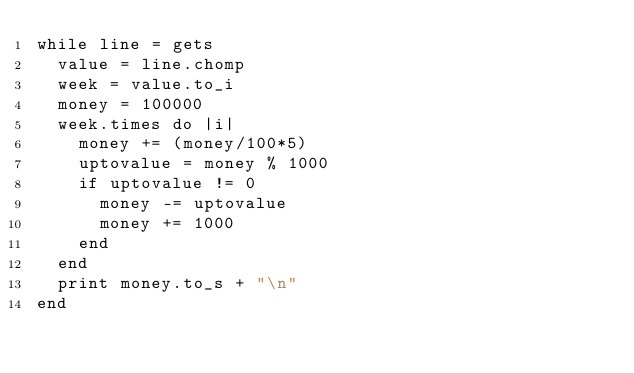Convert code to text. <code><loc_0><loc_0><loc_500><loc_500><_Ruby_>while line = gets
  value = line.chomp
  week = value.to_i
  money = 100000
  week.times do |i|
    money += (money/100*5)
    uptovalue = money % 1000
    if uptovalue != 0
      money -= uptovalue
      money += 1000
    end
  end
  print money.to_s + "\n"
end

</code> 